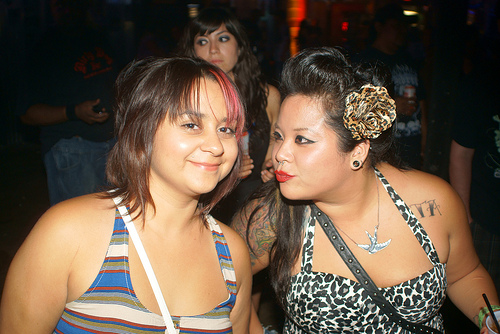<image>
Can you confirm if the dress is on the lady? No. The dress is not positioned on the lady. They may be near each other, but the dress is not supported by or resting on top of the lady. Where is the women in relation to the women? Is it next to the women? Yes. The women is positioned adjacent to the women, located nearby in the same general area. 